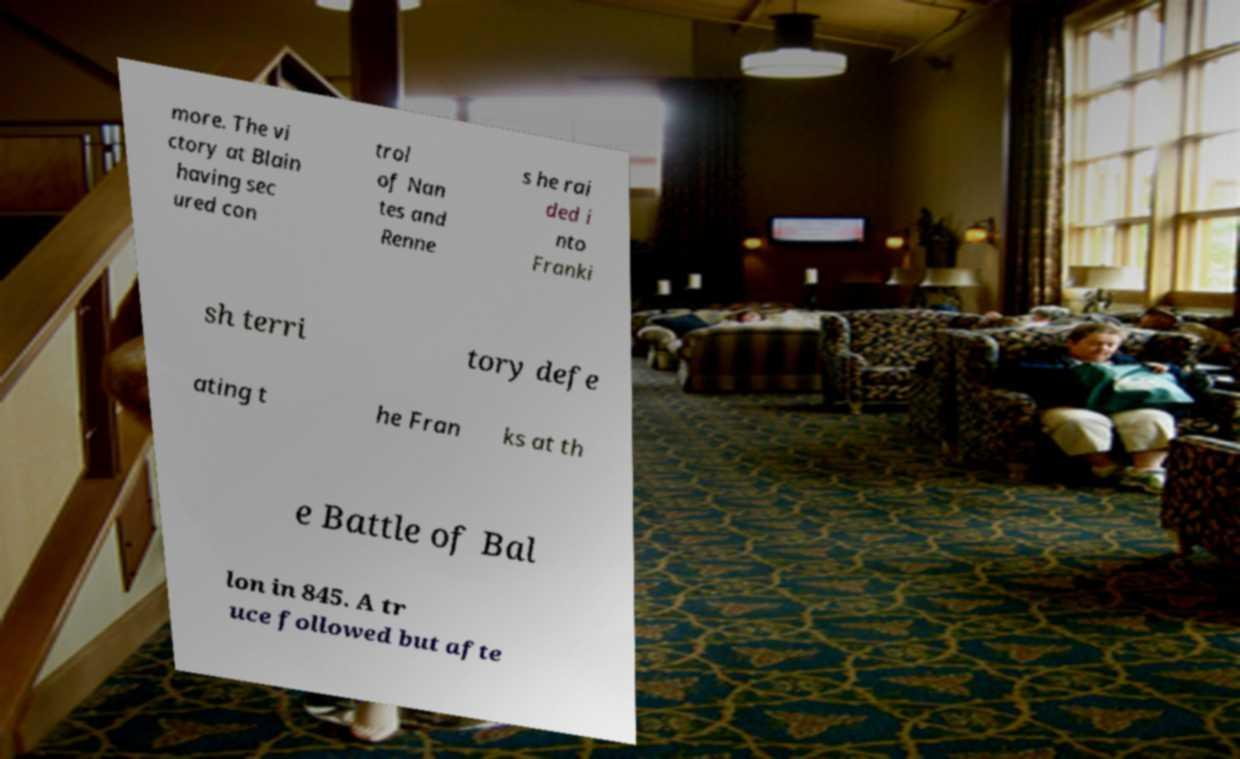What messages or text are displayed in this image? I need them in a readable, typed format. more. The vi ctory at Blain having sec ured con trol of Nan tes and Renne s he rai ded i nto Franki sh terri tory defe ating t he Fran ks at th e Battle of Bal lon in 845. A tr uce followed but afte 